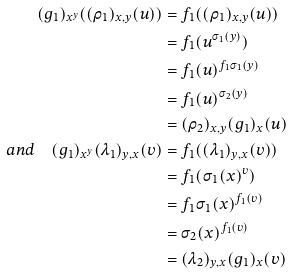<formula> <loc_0><loc_0><loc_500><loc_500>( g _ { 1 } ) _ { x ^ { y } } ( ( \rho _ { 1 } ) _ { x , y } ( u ) ) & = f _ { 1 } ( ( \rho _ { 1 } ) _ { x , y } ( u ) ) \\ & = f _ { 1 } ( u ^ { \sigma _ { 1 } ( y ) } ) \\ & = f _ { 1 } ( u ) ^ { f _ { 1 } \sigma _ { 1 } ( y ) } \\ & = f _ { 1 } ( u ) ^ { \sigma _ { 2 } ( y ) } \\ & = ( \rho _ { 2 } ) _ { x , y } ( g _ { 1 } ) _ { x } ( u ) \\ a n d \quad ( g _ { 1 } ) _ { x ^ { y } } ( \lambda _ { 1 } ) _ { y , x } ( v ) & = f _ { 1 } ( ( \lambda _ { 1 } ) _ { y , x } ( v ) ) \\ & = f _ { 1 } ( \sigma _ { 1 } ( x ) ^ { v } ) \\ & = f _ { 1 } \sigma _ { 1 } ( x ) ^ { f _ { 1 } ( v ) } \\ & = \sigma _ { 2 } ( x ) ^ { f _ { 1 } ( v ) } \\ & = ( \lambda _ { 2 } ) _ { y , x } ( g _ { 1 } ) _ { x } ( v )</formula> 